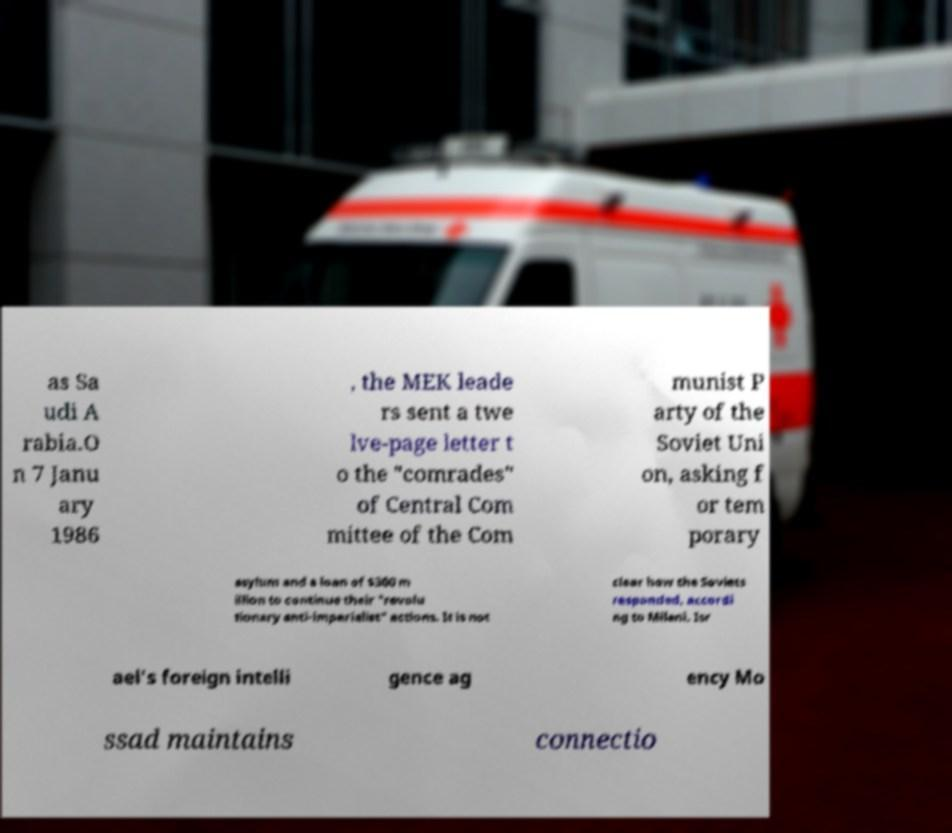For documentation purposes, I need the text within this image transcribed. Could you provide that? as Sa udi A rabia.O n 7 Janu ary 1986 , the MEK leade rs sent a twe lve-page letter t o the "comrades" of Central Com mittee of the Com munist P arty of the Soviet Uni on, asking f or tem porary asylum and a loan of $300 m illion to continue their "revolu tionary anti-imperialist" actions. It is not clear how the Soviets responded, accordi ng to Milani. Isr ael's foreign intelli gence ag ency Mo ssad maintains connectio 